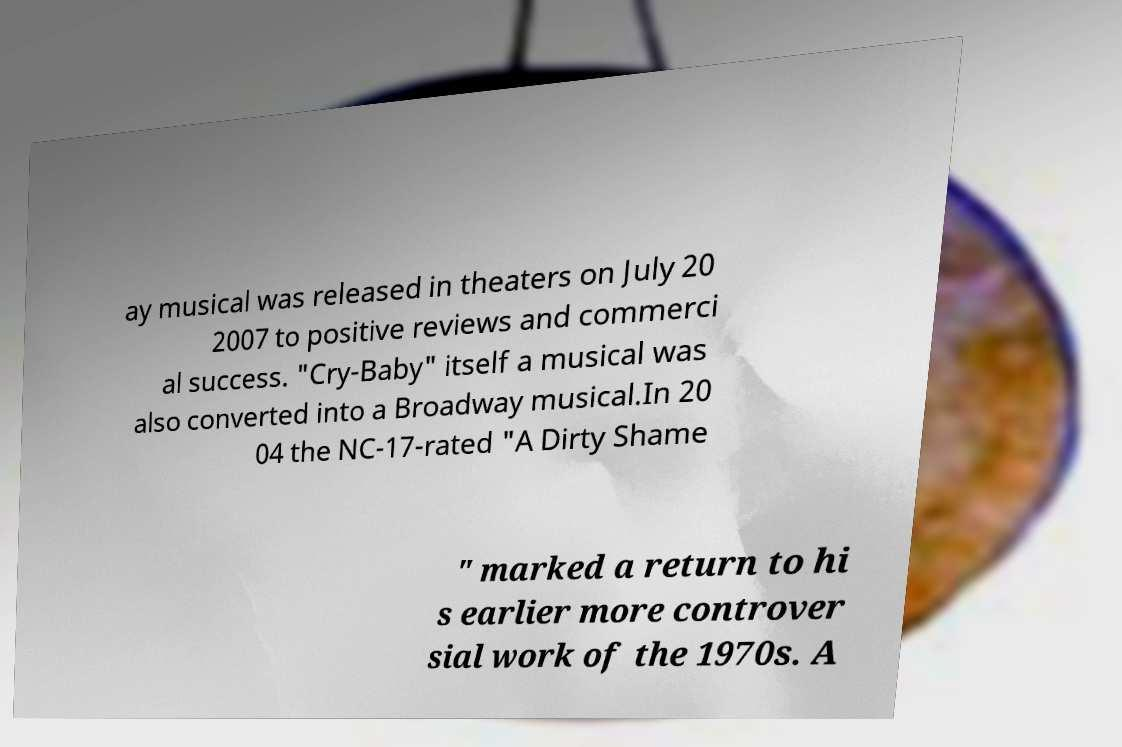Can you read and provide the text displayed in the image?This photo seems to have some interesting text. Can you extract and type it out for me? ay musical was released in theaters on July 20 2007 to positive reviews and commerci al success. "Cry-Baby" itself a musical was also converted into a Broadway musical.In 20 04 the NC-17-rated "A Dirty Shame " marked a return to hi s earlier more controver sial work of the 1970s. A 